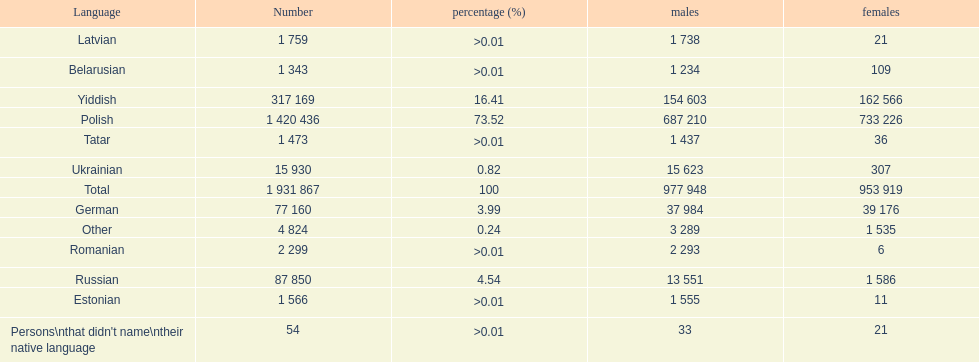Which language had the smallest number of females speaking it. Romanian. 